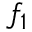<formula> <loc_0><loc_0><loc_500><loc_500>f _ { 1 }</formula> 